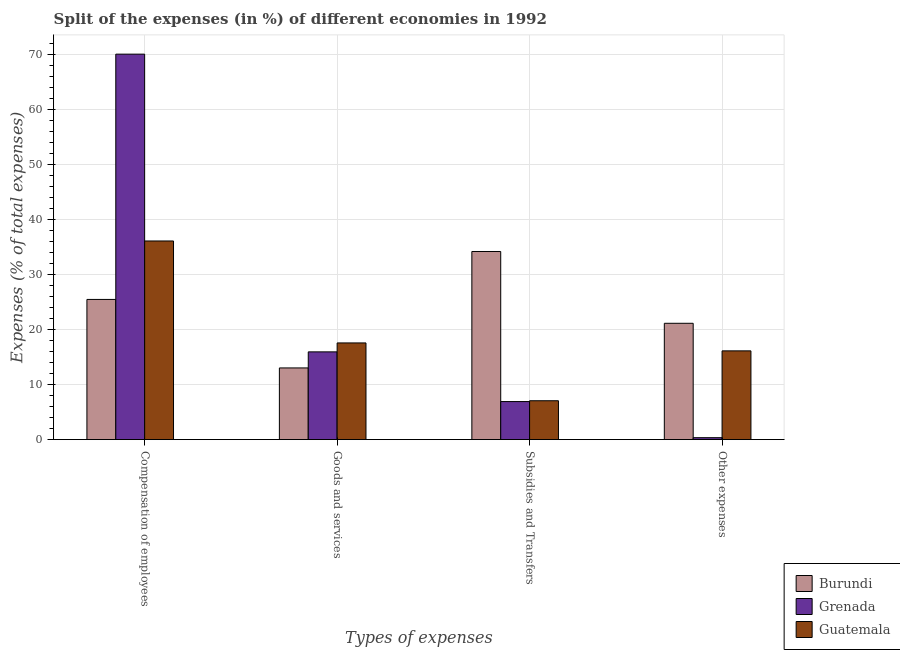How many different coloured bars are there?
Offer a very short reply. 3. How many groups of bars are there?
Offer a terse response. 4. Are the number of bars per tick equal to the number of legend labels?
Offer a very short reply. Yes. What is the label of the 1st group of bars from the left?
Provide a short and direct response. Compensation of employees. What is the percentage of amount spent on subsidies in Burundi?
Provide a short and direct response. 34.17. Across all countries, what is the maximum percentage of amount spent on goods and services?
Provide a short and direct response. 17.56. Across all countries, what is the minimum percentage of amount spent on goods and services?
Provide a succinct answer. 13.02. In which country was the percentage of amount spent on other expenses maximum?
Your answer should be compact. Burundi. In which country was the percentage of amount spent on compensation of employees minimum?
Ensure brevity in your answer.  Burundi. What is the total percentage of amount spent on compensation of employees in the graph?
Provide a short and direct response. 131.57. What is the difference between the percentage of amount spent on goods and services in Burundi and that in Guatemala?
Your response must be concise. -4.54. What is the difference between the percentage of amount spent on other expenses in Burundi and the percentage of amount spent on compensation of employees in Grenada?
Offer a very short reply. -48.89. What is the average percentage of amount spent on compensation of employees per country?
Offer a terse response. 43.86. What is the difference between the percentage of amount spent on subsidies and percentage of amount spent on compensation of employees in Burundi?
Keep it short and to the point. 8.71. In how many countries, is the percentage of amount spent on subsidies greater than 42 %?
Offer a very short reply. 0. What is the ratio of the percentage of amount spent on compensation of employees in Grenada to that in Burundi?
Offer a very short reply. 2.75. Is the percentage of amount spent on goods and services in Grenada less than that in Burundi?
Give a very brief answer. No. What is the difference between the highest and the second highest percentage of amount spent on compensation of employees?
Give a very brief answer. 33.94. What is the difference between the highest and the lowest percentage of amount spent on compensation of employees?
Offer a very short reply. 44.56. In how many countries, is the percentage of amount spent on compensation of employees greater than the average percentage of amount spent on compensation of employees taken over all countries?
Your answer should be very brief. 1. Is the sum of the percentage of amount spent on goods and services in Guatemala and Burundi greater than the maximum percentage of amount spent on other expenses across all countries?
Your answer should be very brief. Yes. Is it the case that in every country, the sum of the percentage of amount spent on goods and services and percentage of amount spent on other expenses is greater than the sum of percentage of amount spent on compensation of employees and percentage of amount spent on subsidies?
Keep it short and to the point. No. What does the 2nd bar from the left in Compensation of employees represents?
Your answer should be compact. Grenada. What does the 1st bar from the right in Compensation of employees represents?
Give a very brief answer. Guatemala. Is it the case that in every country, the sum of the percentage of amount spent on compensation of employees and percentage of amount spent on goods and services is greater than the percentage of amount spent on subsidies?
Keep it short and to the point. Yes. How many bars are there?
Your answer should be very brief. 12. Are all the bars in the graph horizontal?
Provide a succinct answer. No. What is the difference between two consecutive major ticks on the Y-axis?
Make the answer very short. 10. Are the values on the major ticks of Y-axis written in scientific E-notation?
Ensure brevity in your answer.  No. Does the graph contain any zero values?
Provide a succinct answer. No. Does the graph contain grids?
Your answer should be compact. Yes. How many legend labels are there?
Offer a very short reply. 3. How are the legend labels stacked?
Provide a short and direct response. Vertical. What is the title of the graph?
Provide a succinct answer. Split of the expenses (in %) of different economies in 1992. What is the label or title of the X-axis?
Your response must be concise. Types of expenses. What is the label or title of the Y-axis?
Offer a very short reply. Expenses (% of total expenses). What is the Expenses (% of total expenses) of Burundi in Compensation of employees?
Keep it short and to the point. 25.46. What is the Expenses (% of total expenses) in Grenada in Compensation of employees?
Offer a very short reply. 70.02. What is the Expenses (% of total expenses) of Guatemala in Compensation of employees?
Your answer should be very brief. 36.08. What is the Expenses (% of total expenses) in Burundi in Goods and services?
Keep it short and to the point. 13.02. What is the Expenses (% of total expenses) of Grenada in Goods and services?
Offer a terse response. 15.94. What is the Expenses (% of total expenses) of Guatemala in Goods and services?
Offer a very short reply. 17.56. What is the Expenses (% of total expenses) of Burundi in Subsidies and Transfers?
Keep it short and to the point. 34.17. What is the Expenses (% of total expenses) of Grenada in Subsidies and Transfers?
Ensure brevity in your answer.  6.91. What is the Expenses (% of total expenses) of Guatemala in Subsidies and Transfers?
Keep it short and to the point. 7.06. What is the Expenses (% of total expenses) in Burundi in Other expenses?
Keep it short and to the point. 21.13. What is the Expenses (% of total expenses) in Grenada in Other expenses?
Ensure brevity in your answer.  0.35. What is the Expenses (% of total expenses) in Guatemala in Other expenses?
Offer a terse response. 16.12. Across all Types of expenses, what is the maximum Expenses (% of total expenses) of Burundi?
Offer a terse response. 34.17. Across all Types of expenses, what is the maximum Expenses (% of total expenses) of Grenada?
Give a very brief answer. 70.02. Across all Types of expenses, what is the maximum Expenses (% of total expenses) of Guatemala?
Your answer should be compact. 36.08. Across all Types of expenses, what is the minimum Expenses (% of total expenses) of Burundi?
Give a very brief answer. 13.02. Across all Types of expenses, what is the minimum Expenses (% of total expenses) of Grenada?
Give a very brief answer. 0.35. Across all Types of expenses, what is the minimum Expenses (% of total expenses) in Guatemala?
Provide a succinct answer. 7.06. What is the total Expenses (% of total expenses) of Burundi in the graph?
Your answer should be very brief. 93.78. What is the total Expenses (% of total expenses) in Grenada in the graph?
Your answer should be compact. 93.22. What is the total Expenses (% of total expenses) of Guatemala in the graph?
Offer a very short reply. 76.82. What is the difference between the Expenses (% of total expenses) of Burundi in Compensation of employees and that in Goods and services?
Provide a short and direct response. 12.44. What is the difference between the Expenses (% of total expenses) of Grenada in Compensation of employees and that in Goods and services?
Your answer should be compact. 54.08. What is the difference between the Expenses (% of total expenses) of Guatemala in Compensation of employees and that in Goods and services?
Give a very brief answer. 18.52. What is the difference between the Expenses (% of total expenses) of Burundi in Compensation of employees and that in Subsidies and Transfers?
Offer a terse response. -8.71. What is the difference between the Expenses (% of total expenses) in Grenada in Compensation of employees and that in Subsidies and Transfers?
Ensure brevity in your answer.  63.11. What is the difference between the Expenses (% of total expenses) of Guatemala in Compensation of employees and that in Subsidies and Transfers?
Ensure brevity in your answer.  29.02. What is the difference between the Expenses (% of total expenses) of Burundi in Compensation of employees and that in Other expenses?
Offer a terse response. 4.33. What is the difference between the Expenses (% of total expenses) of Grenada in Compensation of employees and that in Other expenses?
Give a very brief answer. 69.67. What is the difference between the Expenses (% of total expenses) of Guatemala in Compensation of employees and that in Other expenses?
Give a very brief answer. 19.96. What is the difference between the Expenses (% of total expenses) of Burundi in Goods and services and that in Subsidies and Transfers?
Give a very brief answer. -21.15. What is the difference between the Expenses (% of total expenses) in Grenada in Goods and services and that in Subsidies and Transfers?
Your answer should be very brief. 9.03. What is the difference between the Expenses (% of total expenses) in Guatemala in Goods and services and that in Subsidies and Transfers?
Ensure brevity in your answer.  10.5. What is the difference between the Expenses (% of total expenses) of Burundi in Goods and services and that in Other expenses?
Offer a very short reply. -8.11. What is the difference between the Expenses (% of total expenses) in Grenada in Goods and services and that in Other expenses?
Your response must be concise. 15.59. What is the difference between the Expenses (% of total expenses) of Guatemala in Goods and services and that in Other expenses?
Keep it short and to the point. 1.44. What is the difference between the Expenses (% of total expenses) in Burundi in Subsidies and Transfers and that in Other expenses?
Your response must be concise. 13.04. What is the difference between the Expenses (% of total expenses) in Grenada in Subsidies and Transfers and that in Other expenses?
Keep it short and to the point. 6.56. What is the difference between the Expenses (% of total expenses) of Guatemala in Subsidies and Transfers and that in Other expenses?
Your response must be concise. -9.06. What is the difference between the Expenses (% of total expenses) in Burundi in Compensation of employees and the Expenses (% of total expenses) in Grenada in Goods and services?
Give a very brief answer. 9.53. What is the difference between the Expenses (% of total expenses) of Burundi in Compensation of employees and the Expenses (% of total expenses) of Guatemala in Goods and services?
Offer a terse response. 7.9. What is the difference between the Expenses (% of total expenses) of Grenada in Compensation of employees and the Expenses (% of total expenses) of Guatemala in Goods and services?
Provide a succinct answer. 52.46. What is the difference between the Expenses (% of total expenses) of Burundi in Compensation of employees and the Expenses (% of total expenses) of Grenada in Subsidies and Transfers?
Offer a terse response. 18.55. What is the difference between the Expenses (% of total expenses) of Burundi in Compensation of employees and the Expenses (% of total expenses) of Guatemala in Subsidies and Transfers?
Keep it short and to the point. 18.4. What is the difference between the Expenses (% of total expenses) in Grenada in Compensation of employees and the Expenses (% of total expenses) in Guatemala in Subsidies and Transfers?
Provide a short and direct response. 62.96. What is the difference between the Expenses (% of total expenses) of Burundi in Compensation of employees and the Expenses (% of total expenses) of Grenada in Other expenses?
Make the answer very short. 25.11. What is the difference between the Expenses (% of total expenses) of Burundi in Compensation of employees and the Expenses (% of total expenses) of Guatemala in Other expenses?
Your answer should be very brief. 9.34. What is the difference between the Expenses (% of total expenses) in Grenada in Compensation of employees and the Expenses (% of total expenses) in Guatemala in Other expenses?
Your response must be concise. 53.9. What is the difference between the Expenses (% of total expenses) in Burundi in Goods and services and the Expenses (% of total expenses) in Grenada in Subsidies and Transfers?
Your answer should be very brief. 6.11. What is the difference between the Expenses (% of total expenses) in Burundi in Goods and services and the Expenses (% of total expenses) in Guatemala in Subsidies and Transfers?
Your answer should be very brief. 5.96. What is the difference between the Expenses (% of total expenses) of Grenada in Goods and services and the Expenses (% of total expenses) of Guatemala in Subsidies and Transfers?
Provide a short and direct response. 8.88. What is the difference between the Expenses (% of total expenses) of Burundi in Goods and services and the Expenses (% of total expenses) of Grenada in Other expenses?
Offer a terse response. 12.67. What is the difference between the Expenses (% of total expenses) of Burundi in Goods and services and the Expenses (% of total expenses) of Guatemala in Other expenses?
Give a very brief answer. -3.1. What is the difference between the Expenses (% of total expenses) in Grenada in Goods and services and the Expenses (% of total expenses) in Guatemala in Other expenses?
Your answer should be very brief. -0.18. What is the difference between the Expenses (% of total expenses) of Burundi in Subsidies and Transfers and the Expenses (% of total expenses) of Grenada in Other expenses?
Keep it short and to the point. 33.82. What is the difference between the Expenses (% of total expenses) in Burundi in Subsidies and Transfers and the Expenses (% of total expenses) in Guatemala in Other expenses?
Make the answer very short. 18.05. What is the difference between the Expenses (% of total expenses) of Grenada in Subsidies and Transfers and the Expenses (% of total expenses) of Guatemala in Other expenses?
Your answer should be compact. -9.21. What is the average Expenses (% of total expenses) of Burundi per Types of expenses?
Keep it short and to the point. 23.45. What is the average Expenses (% of total expenses) in Grenada per Types of expenses?
Give a very brief answer. 23.3. What is the average Expenses (% of total expenses) in Guatemala per Types of expenses?
Offer a terse response. 19.21. What is the difference between the Expenses (% of total expenses) in Burundi and Expenses (% of total expenses) in Grenada in Compensation of employees?
Make the answer very short. -44.56. What is the difference between the Expenses (% of total expenses) in Burundi and Expenses (% of total expenses) in Guatemala in Compensation of employees?
Make the answer very short. -10.62. What is the difference between the Expenses (% of total expenses) of Grenada and Expenses (% of total expenses) of Guatemala in Compensation of employees?
Keep it short and to the point. 33.94. What is the difference between the Expenses (% of total expenses) in Burundi and Expenses (% of total expenses) in Grenada in Goods and services?
Provide a succinct answer. -2.92. What is the difference between the Expenses (% of total expenses) of Burundi and Expenses (% of total expenses) of Guatemala in Goods and services?
Your response must be concise. -4.54. What is the difference between the Expenses (% of total expenses) in Grenada and Expenses (% of total expenses) in Guatemala in Goods and services?
Provide a succinct answer. -1.62. What is the difference between the Expenses (% of total expenses) in Burundi and Expenses (% of total expenses) in Grenada in Subsidies and Transfers?
Ensure brevity in your answer.  27.26. What is the difference between the Expenses (% of total expenses) of Burundi and Expenses (% of total expenses) of Guatemala in Subsidies and Transfers?
Offer a very short reply. 27.11. What is the difference between the Expenses (% of total expenses) of Grenada and Expenses (% of total expenses) of Guatemala in Subsidies and Transfers?
Provide a short and direct response. -0.15. What is the difference between the Expenses (% of total expenses) of Burundi and Expenses (% of total expenses) of Grenada in Other expenses?
Offer a very short reply. 20.78. What is the difference between the Expenses (% of total expenses) of Burundi and Expenses (% of total expenses) of Guatemala in Other expenses?
Offer a very short reply. 5.01. What is the difference between the Expenses (% of total expenses) in Grenada and Expenses (% of total expenses) in Guatemala in Other expenses?
Offer a terse response. -15.77. What is the ratio of the Expenses (% of total expenses) of Burundi in Compensation of employees to that in Goods and services?
Your answer should be very brief. 1.96. What is the ratio of the Expenses (% of total expenses) in Grenada in Compensation of employees to that in Goods and services?
Give a very brief answer. 4.39. What is the ratio of the Expenses (% of total expenses) of Guatemala in Compensation of employees to that in Goods and services?
Your response must be concise. 2.05. What is the ratio of the Expenses (% of total expenses) in Burundi in Compensation of employees to that in Subsidies and Transfers?
Your answer should be compact. 0.75. What is the ratio of the Expenses (% of total expenses) of Grenada in Compensation of employees to that in Subsidies and Transfers?
Your response must be concise. 10.13. What is the ratio of the Expenses (% of total expenses) in Guatemala in Compensation of employees to that in Subsidies and Transfers?
Offer a terse response. 5.11. What is the ratio of the Expenses (% of total expenses) in Burundi in Compensation of employees to that in Other expenses?
Your response must be concise. 1.21. What is the ratio of the Expenses (% of total expenses) of Grenada in Compensation of employees to that in Other expenses?
Keep it short and to the point. 199.65. What is the ratio of the Expenses (% of total expenses) of Guatemala in Compensation of employees to that in Other expenses?
Offer a very short reply. 2.24. What is the ratio of the Expenses (% of total expenses) of Burundi in Goods and services to that in Subsidies and Transfers?
Offer a terse response. 0.38. What is the ratio of the Expenses (% of total expenses) of Grenada in Goods and services to that in Subsidies and Transfers?
Your answer should be compact. 2.31. What is the ratio of the Expenses (% of total expenses) in Guatemala in Goods and services to that in Subsidies and Transfers?
Your response must be concise. 2.49. What is the ratio of the Expenses (% of total expenses) in Burundi in Goods and services to that in Other expenses?
Your answer should be very brief. 0.62. What is the ratio of the Expenses (% of total expenses) in Grenada in Goods and services to that in Other expenses?
Provide a succinct answer. 45.44. What is the ratio of the Expenses (% of total expenses) of Guatemala in Goods and services to that in Other expenses?
Offer a very short reply. 1.09. What is the ratio of the Expenses (% of total expenses) of Burundi in Subsidies and Transfers to that in Other expenses?
Make the answer very short. 1.62. What is the ratio of the Expenses (% of total expenses) of Grenada in Subsidies and Transfers to that in Other expenses?
Provide a short and direct response. 19.7. What is the ratio of the Expenses (% of total expenses) in Guatemala in Subsidies and Transfers to that in Other expenses?
Make the answer very short. 0.44. What is the difference between the highest and the second highest Expenses (% of total expenses) of Burundi?
Offer a very short reply. 8.71. What is the difference between the highest and the second highest Expenses (% of total expenses) of Grenada?
Keep it short and to the point. 54.08. What is the difference between the highest and the second highest Expenses (% of total expenses) of Guatemala?
Give a very brief answer. 18.52. What is the difference between the highest and the lowest Expenses (% of total expenses) of Burundi?
Keep it short and to the point. 21.15. What is the difference between the highest and the lowest Expenses (% of total expenses) of Grenada?
Your answer should be very brief. 69.67. What is the difference between the highest and the lowest Expenses (% of total expenses) in Guatemala?
Provide a short and direct response. 29.02. 